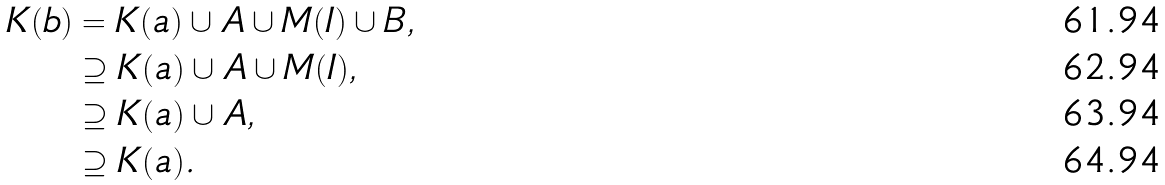<formula> <loc_0><loc_0><loc_500><loc_500>K ( b ) & = K ( a ) \cup A \cup M ( I ) \cup B , \\ & \supseteq K ( a ) \cup A \cup M ( I ) , \\ & \supseteq K ( a ) \cup A , \\ & \supseteq K ( a ) .</formula> 